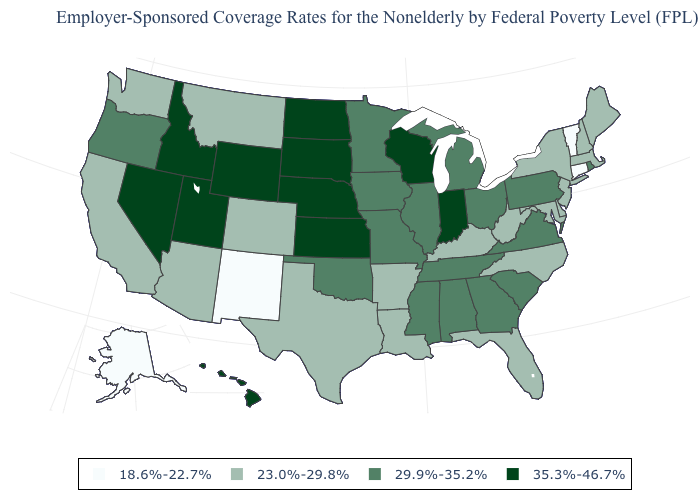How many symbols are there in the legend?
Give a very brief answer. 4. How many symbols are there in the legend?
Give a very brief answer. 4. Which states have the highest value in the USA?
Keep it brief. Hawaii, Idaho, Indiana, Kansas, Nebraska, Nevada, North Dakota, South Dakota, Utah, Wisconsin, Wyoming. What is the value of Oregon?
Quick response, please. 29.9%-35.2%. Does Kentucky have the highest value in the South?
Quick response, please. No. What is the value of New Jersey?
Quick response, please. 23.0%-29.8%. What is the value of Georgia?
Be succinct. 29.9%-35.2%. What is the lowest value in the Northeast?
Concise answer only. 18.6%-22.7%. Is the legend a continuous bar?
Quick response, please. No. Does the map have missing data?
Be succinct. No. Among the states that border Rhode Island , does Massachusetts have the highest value?
Answer briefly. Yes. Which states have the highest value in the USA?
Write a very short answer. Hawaii, Idaho, Indiana, Kansas, Nebraska, Nevada, North Dakota, South Dakota, Utah, Wisconsin, Wyoming. Name the states that have a value in the range 18.6%-22.7%?
Give a very brief answer. Alaska, Connecticut, New Mexico, Vermont. Does New York have a higher value than Connecticut?
Concise answer only. Yes. What is the value of Wisconsin?
Quick response, please. 35.3%-46.7%. 